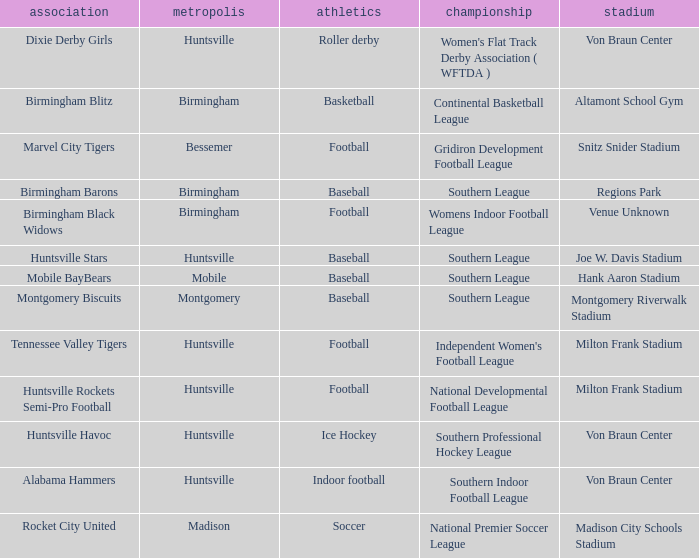Which city has a club called the Huntsville Stars? Huntsville. Can you parse all the data within this table? {'header': ['association', 'metropolis', 'athletics', 'championship', 'stadium'], 'rows': [['Dixie Derby Girls', 'Huntsville', 'Roller derby', "Women's Flat Track Derby Association ( WFTDA )", 'Von Braun Center'], ['Birmingham Blitz', 'Birmingham', 'Basketball', 'Continental Basketball League', 'Altamont School Gym'], ['Marvel City Tigers', 'Bessemer', 'Football', 'Gridiron Development Football League', 'Snitz Snider Stadium'], ['Birmingham Barons', 'Birmingham', 'Baseball', 'Southern League', 'Regions Park'], ['Birmingham Black Widows', 'Birmingham', 'Football', 'Womens Indoor Football League', 'Venue Unknown'], ['Huntsville Stars', 'Huntsville', 'Baseball', 'Southern League', 'Joe W. Davis Stadium'], ['Mobile BayBears', 'Mobile', 'Baseball', 'Southern League', 'Hank Aaron Stadium'], ['Montgomery Biscuits', 'Montgomery', 'Baseball', 'Southern League', 'Montgomery Riverwalk Stadium'], ['Tennessee Valley Tigers', 'Huntsville', 'Football', "Independent Women's Football League", 'Milton Frank Stadium'], ['Huntsville Rockets Semi-Pro Football', 'Huntsville', 'Football', 'National Developmental Football League', 'Milton Frank Stadium'], ['Huntsville Havoc', 'Huntsville', 'Ice Hockey', 'Southern Professional Hockey League', 'Von Braun Center'], ['Alabama Hammers', 'Huntsville', 'Indoor football', 'Southern Indoor Football League', 'Von Braun Center'], ['Rocket City United', 'Madison', 'Soccer', 'National Premier Soccer League', 'Madison City Schools Stadium']]} 